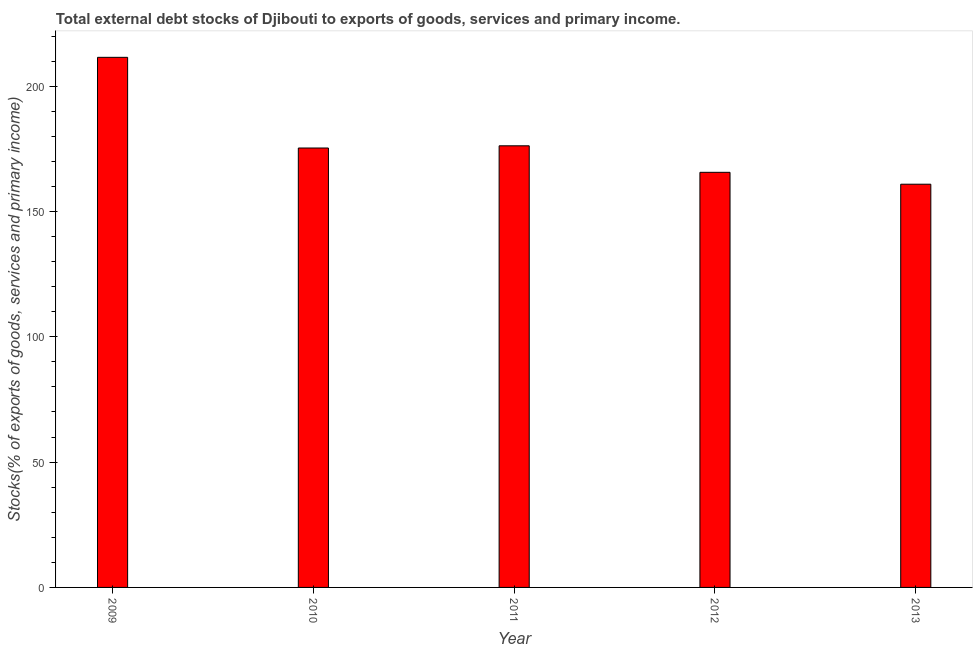Does the graph contain grids?
Give a very brief answer. No. What is the title of the graph?
Your answer should be very brief. Total external debt stocks of Djibouti to exports of goods, services and primary income. What is the label or title of the Y-axis?
Offer a very short reply. Stocks(% of exports of goods, services and primary income). What is the external debt stocks in 2010?
Offer a very short reply. 175.32. Across all years, what is the maximum external debt stocks?
Offer a terse response. 211.5. Across all years, what is the minimum external debt stocks?
Provide a succinct answer. 160.87. In which year was the external debt stocks maximum?
Provide a succinct answer. 2009. What is the sum of the external debt stocks?
Offer a very short reply. 889.51. What is the difference between the external debt stocks in 2009 and 2012?
Keep it short and to the point. 45.88. What is the average external debt stocks per year?
Make the answer very short. 177.9. What is the median external debt stocks?
Keep it short and to the point. 175.32. What is the ratio of the external debt stocks in 2010 to that in 2012?
Provide a succinct answer. 1.06. Is the external debt stocks in 2009 less than that in 2011?
Keep it short and to the point. No. What is the difference between the highest and the second highest external debt stocks?
Your answer should be very brief. 35.3. Is the sum of the external debt stocks in 2010 and 2013 greater than the maximum external debt stocks across all years?
Provide a succinct answer. Yes. What is the difference between the highest and the lowest external debt stocks?
Provide a succinct answer. 50.62. In how many years, is the external debt stocks greater than the average external debt stocks taken over all years?
Your answer should be very brief. 1. How many bars are there?
Ensure brevity in your answer.  5. Are all the bars in the graph horizontal?
Provide a short and direct response. No. How many years are there in the graph?
Keep it short and to the point. 5. What is the difference between two consecutive major ticks on the Y-axis?
Your answer should be compact. 50. Are the values on the major ticks of Y-axis written in scientific E-notation?
Your answer should be very brief. No. What is the Stocks(% of exports of goods, services and primary income) of 2009?
Offer a very short reply. 211.5. What is the Stocks(% of exports of goods, services and primary income) of 2010?
Give a very brief answer. 175.32. What is the Stocks(% of exports of goods, services and primary income) in 2011?
Your answer should be compact. 176.2. What is the Stocks(% of exports of goods, services and primary income) of 2012?
Your answer should be very brief. 165.62. What is the Stocks(% of exports of goods, services and primary income) in 2013?
Provide a short and direct response. 160.87. What is the difference between the Stocks(% of exports of goods, services and primary income) in 2009 and 2010?
Give a very brief answer. 36.18. What is the difference between the Stocks(% of exports of goods, services and primary income) in 2009 and 2011?
Your answer should be very brief. 35.3. What is the difference between the Stocks(% of exports of goods, services and primary income) in 2009 and 2012?
Ensure brevity in your answer.  45.88. What is the difference between the Stocks(% of exports of goods, services and primary income) in 2009 and 2013?
Your answer should be very brief. 50.62. What is the difference between the Stocks(% of exports of goods, services and primary income) in 2010 and 2011?
Your answer should be very brief. -0.88. What is the difference between the Stocks(% of exports of goods, services and primary income) in 2010 and 2012?
Provide a succinct answer. 9.7. What is the difference between the Stocks(% of exports of goods, services and primary income) in 2010 and 2013?
Your response must be concise. 14.44. What is the difference between the Stocks(% of exports of goods, services and primary income) in 2011 and 2012?
Your response must be concise. 10.58. What is the difference between the Stocks(% of exports of goods, services and primary income) in 2011 and 2013?
Keep it short and to the point. 15.32. What is the difference between the Stocks(% of exports of goods, services and primary income) in 2012 and 2013?
Your response must be concise. 4.74. What is the ratio of the Stocks(% of exports of goods, services and primary income) in 2009 to that in 2010?
Provide a succinct answer. 1.21. What is the ratio of the Stocks(% of exports of goods, services and primary income) in 2009 to that in 2011?
Provide a succinct answer. 1.2. What is the ratio of the Stocks(% of exports of goods, services and primary income) in 2009 to that in 2012?
Offer a very short reply. 1.28. What is the ratio of the Stocks(% of exports of goods, services and primary income) in 2009 to that in 2013?
Make the answer very short. 1.31. What is the ratio of the Stocks(% of exports of goods, services and primary income) in 2010 to that in 2012?
Provide a succinct answer. 1.06. What is the ratio of the Stocks(% of exports of goods, services and primary income) in 2010 to that in 2013?
Make the answer very short. 1.09. What is the ratio of the Stocks(% of exports of goods, services and primary income) in 2011 to that in 2012?
Give a very brief answer. 1.06. What is the ratio of the Stocks(% of exports of goods, services and primary income) in 2011 to that in 2013?
Ensure brevity in your answer.  1.09. 